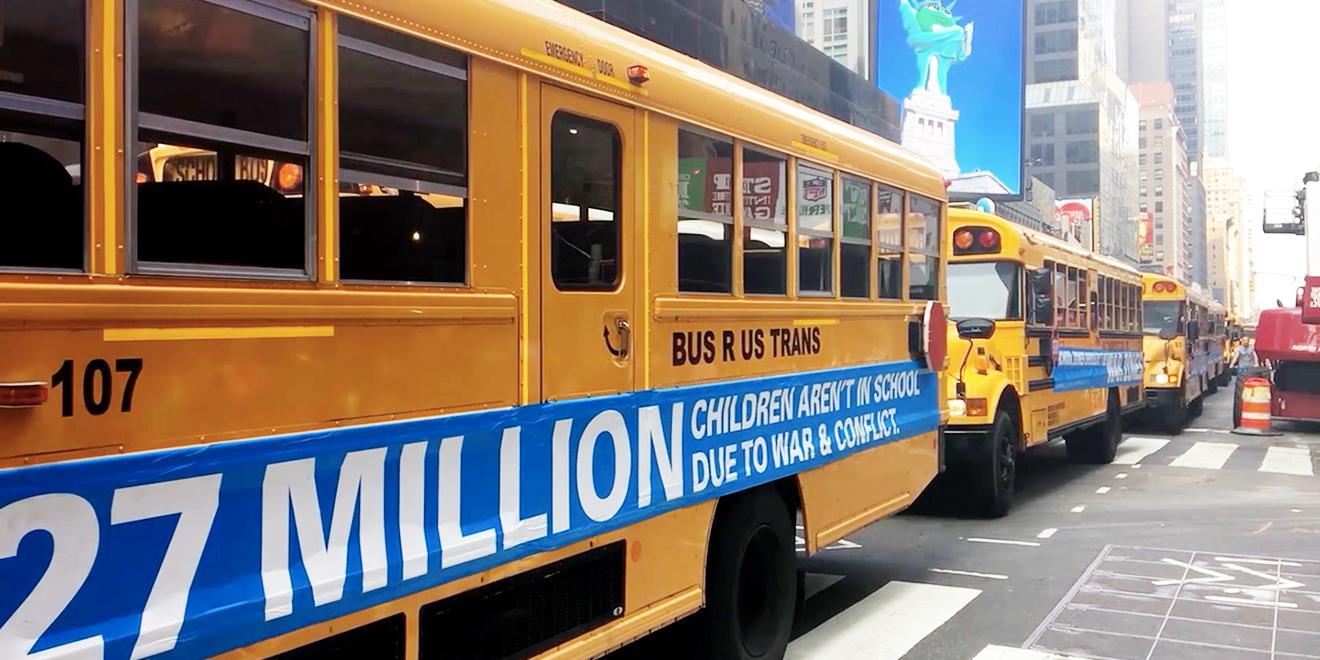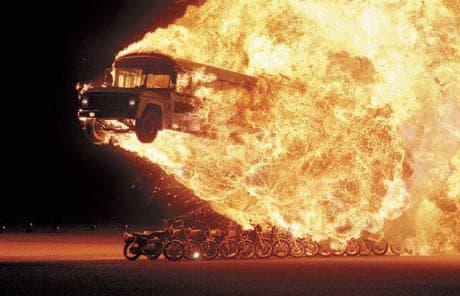The first image is the image on the left, the second image is the image on the right. Evaluate the accuracy of this statement regarding the images: "The right image contains a school bus that is airborne being launched over objects.". Is it true? Answer yes or no. Yes. The first image is the image on the left, the second image is the image on the right. Assess this claim about the two images: "Both images feature buses performing stunts, and at least one image shows a yellow bus performing a wheelie with front wheels off the ground.". Correct or not? Answer yes or no. No. 